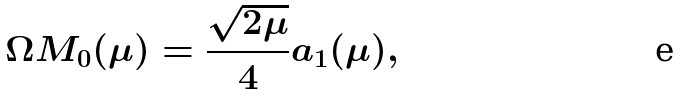<formula> <loc_0><loc_0><loc_500><loc_500>\Omega M _ { 0 } ( \mu ) = \frac { \sqrt { 2 \mu } } { 4 } a _ { 1 } ( \mu ) ,</formula> 